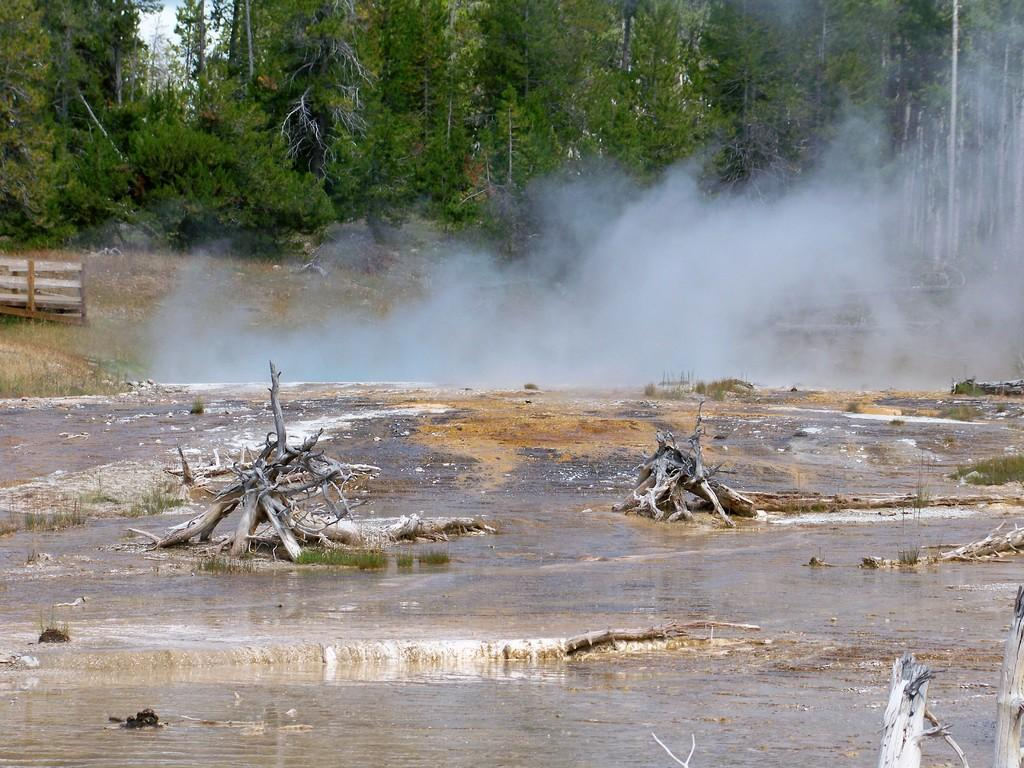What is the primary element present in the image? There is water in the image. What type of objects can be seen in the water? There are wooden trunks in the image. What can be seen in the background of the image? There is smoke and trees visible in the background of the image. How many people are in jail in the image? There is no jail or people in jail present in the image. What type of mass is being held in the image? There is no mass or religious gathering present in the image. 